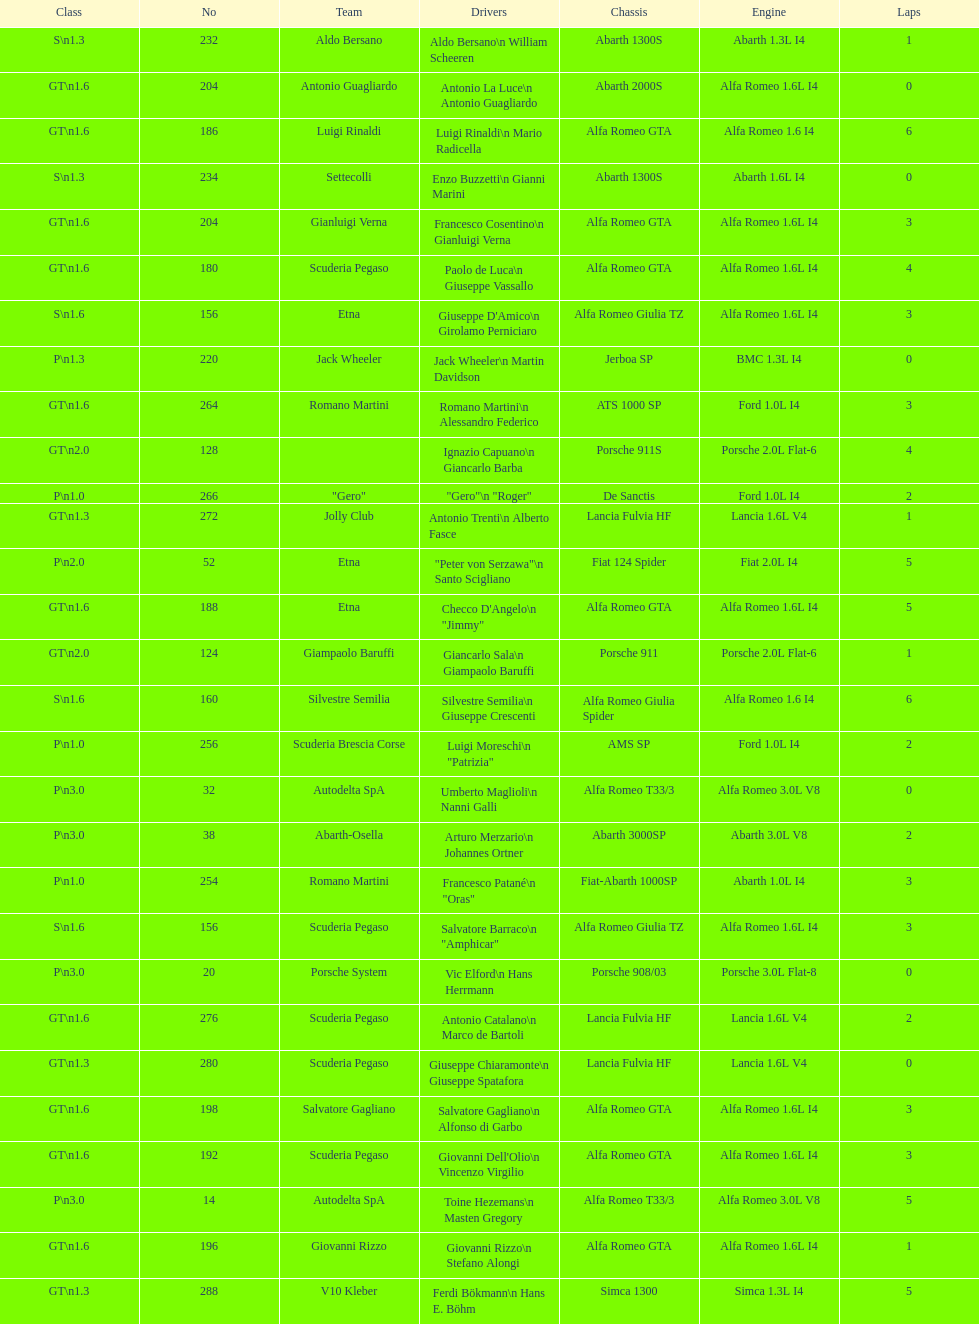How many teams failed to finish the race after 2 laps? 4. 